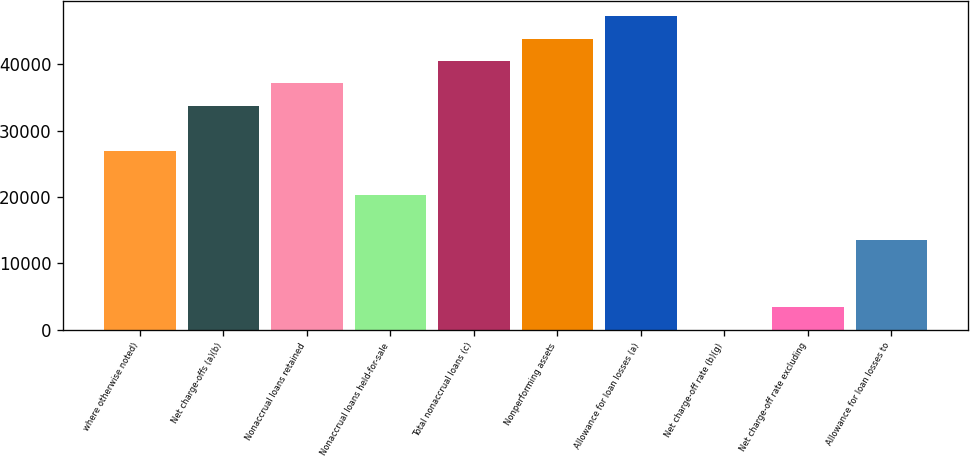Convert chart. <chart><loc_0><loc_0><loc_500><loc_500><bar_chart><fcel>where otherwise noted)<fcel>Net charge-offs (a)(b)<fcel>Nonaccrual loans retained<fcel>Nonaccrual loans held-for-sale<fcel>Total nonaccrual loans (c)<fcel>Nonperforming assets<fcel>Allowance for loan losses (a)<fcel>Net charge-off rate (b)(g)<fcel>Net charge-off rate excluding<fcel>Allowance for loan losses to<nl><fcel>26993.9<fcel>33742<fcel>37116<fcel>20245.8<fcel>40490.1<fcel>43864.1<fcel>47238.2<fcel>1.48<fcel>3375.53<fcel>13497.7<nl></chart> 